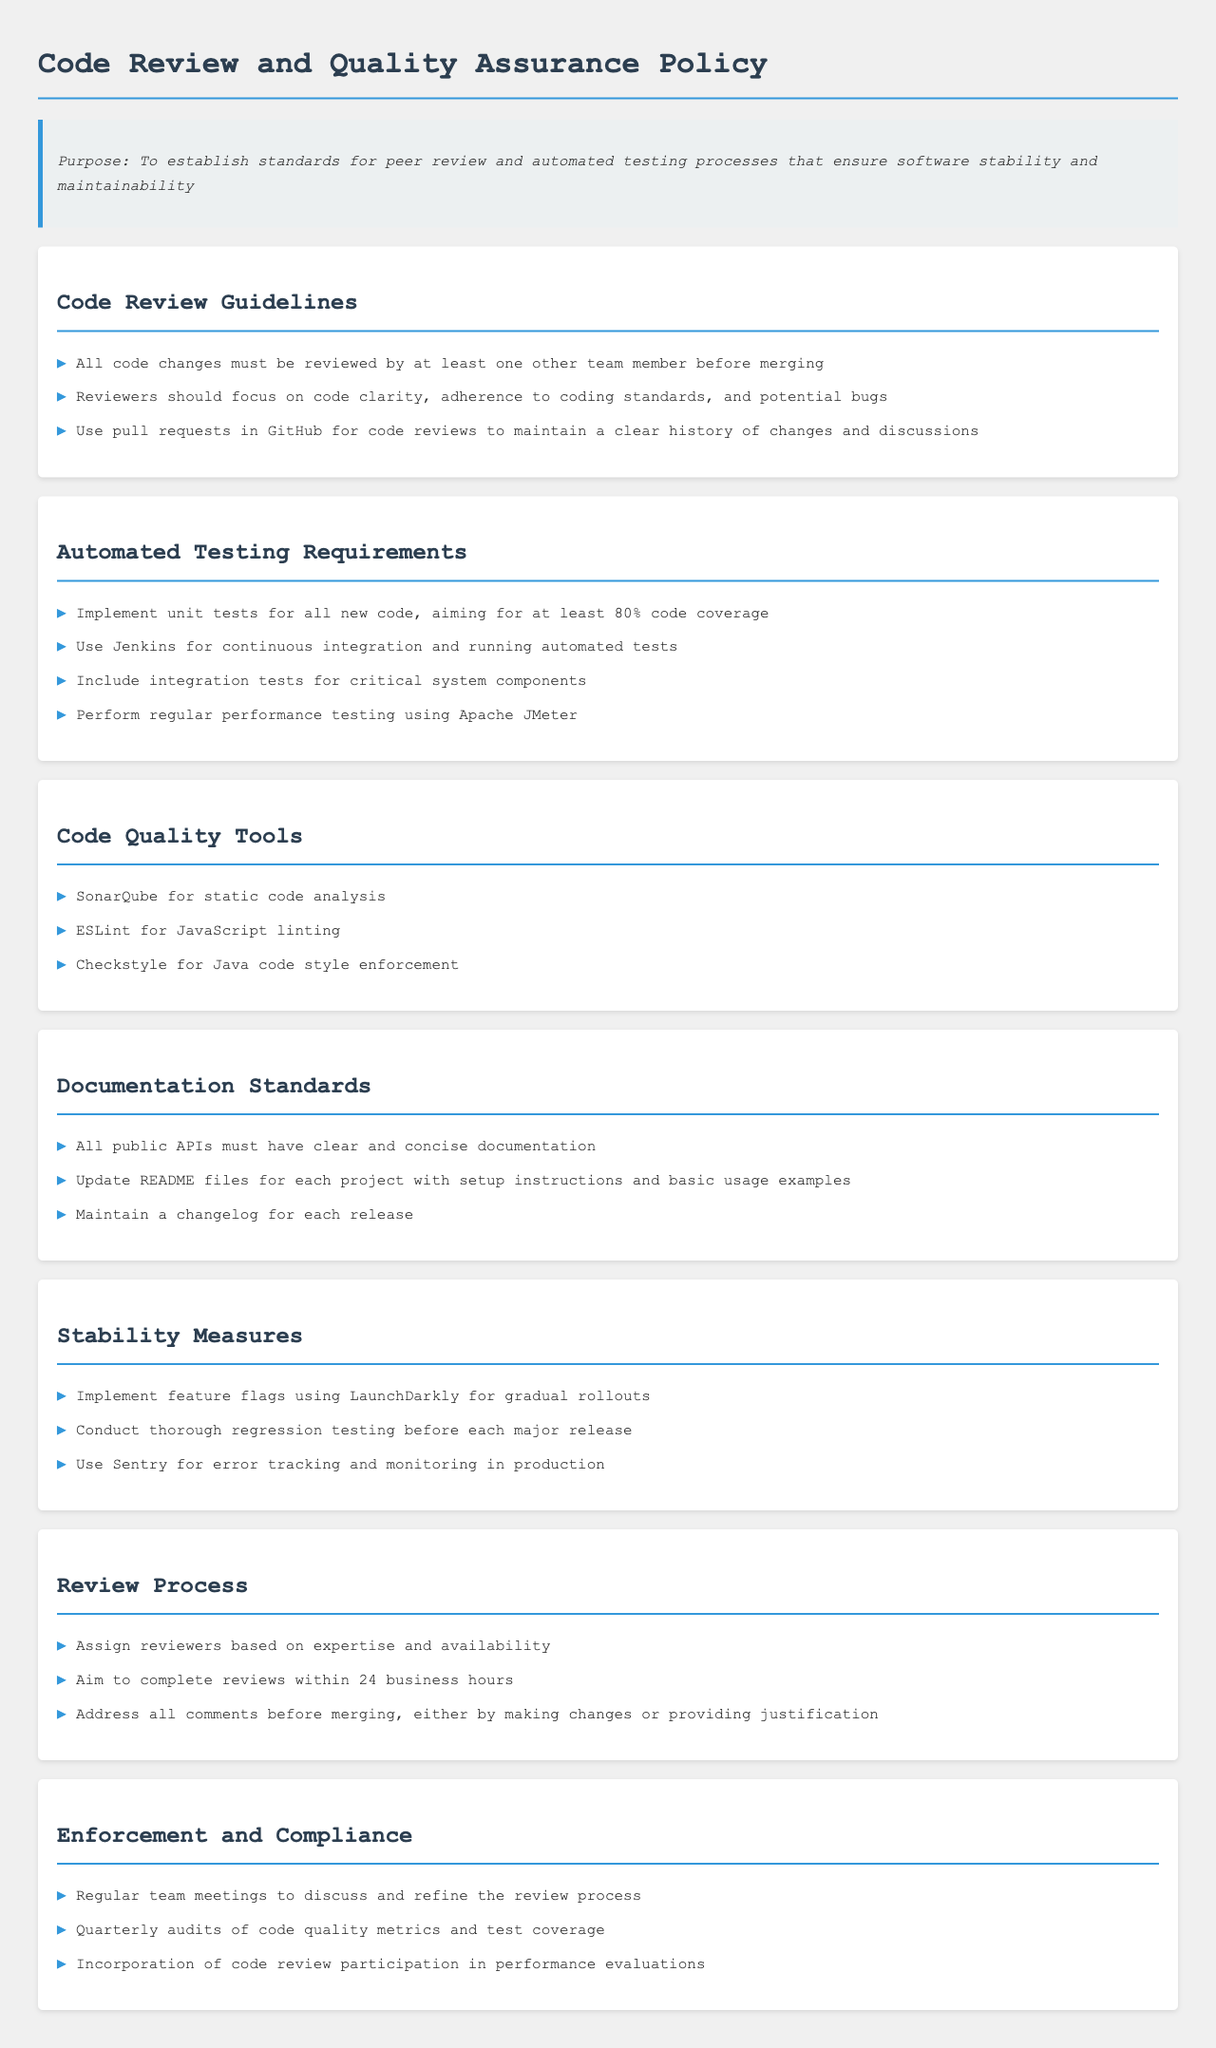What is the required code coverage for new code? The required code coverage for new code is specified in the automated testing requirements.
Answer: 80% Who must review all code changes? The document states that code changes must be reviewed by someone within the team.
Answer: One other team member What is the tool used for static code analysis? The code quality tools section lists the tools used, including the one for static analysis.
Answer: SonarQube How long should code reviews aim to be completed? The review process section mentions a specific time frame for completing reviews.
Answer: 24 business hours What is used for error tracking and monitoring in production? The stability measures section mentions a tool specifically for tracking errors.
Answer: Sentry What type of testing must be included for critical system components? The automated testing requirements specify a type of testing for critical components.
Answer: Integration tests What should all public APIs have? The documentation standards section outlines requirements for public APIs.
Answer: Clear and concise documentation What is used for gradual rollouts? The stability measures section discusses a specific tool for managing rollouts.
Answer: LaunchDarkly What is the frequency of the audits of code quality metrics? The enforcement and compliance section describes how often these audits are conducted.
Answer: Quarterly 